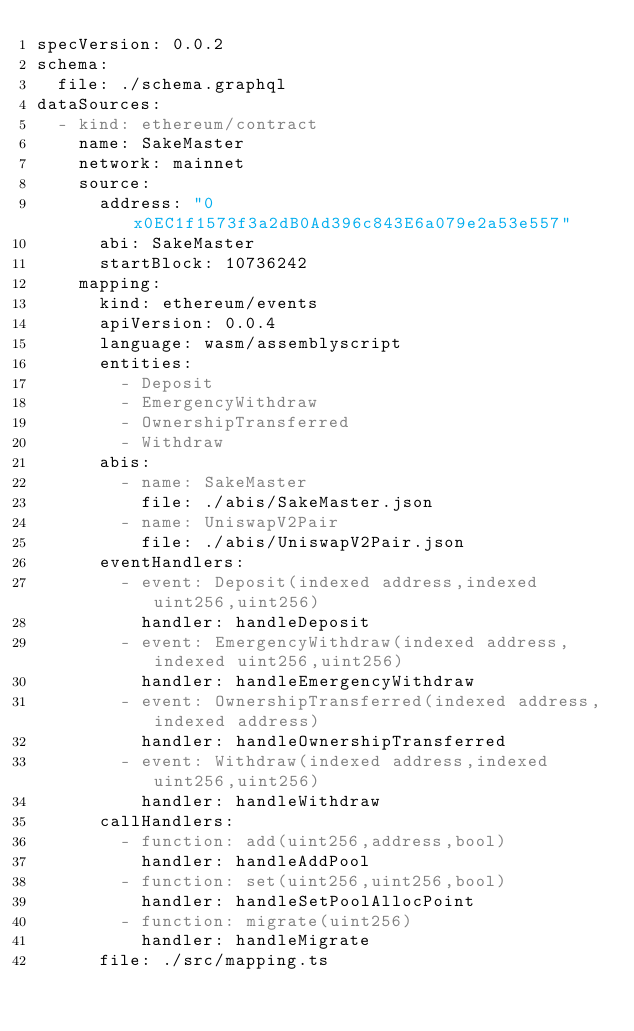Convert code to text. <code><loc_0><loc_0><loc_500><loc_500><_YAML_>specVersion: 0.0.2
schema:
  file: ./schema.graphql
dataSources:
  - kind: ethereum/contract
    name: SakeMaster
    network: mainnet
    source:
      address: "0x0EC1f1573f3a2dB0Ad396c843E6a079e2a53e557"
      abi: SakeMaster
      startBlock: 10736242
    mapping:
      kind: ethereum/events
      apiVersion: 0.0.4
      language: wasm/assemblyscript
      entities:
        - Deposit
        - EmergencyWithdraw
        - OwnershipTransferred
        - Withdraw
      abis:
        - name: SakeMaster
          file: ./abis/SakeMaster.json
        - name: UniswapV2Pair
          file: ./abis/UniswapV2Pair.json
      eventHandlers:
        - event: Deposit(indexed address,indexed uint256,uint256)
          handler: handleDeposit
        - event: EmergencyWithdraw(indexed address,indexed uint256,uint256)
          handler: handleEmergencyWithdraw
        - event: OwnershipTransferred(indexed address,indexed address)
          handler: handleOwnershipTransferred
        - event: Withdraw(indexed address,indexed uint256,uint256)
          handler: handleWithdraw
      callHandlers:
        - function: add(uint256,address,bool)
          handler: handleAddPool
        - function: set(uint256,uint256,bool)
          handler: handleSetPoolAllocPoint
        - function: migrate(uint256)
          handler: handleMigrate
      file: ./src/mapping.ts
</code> 